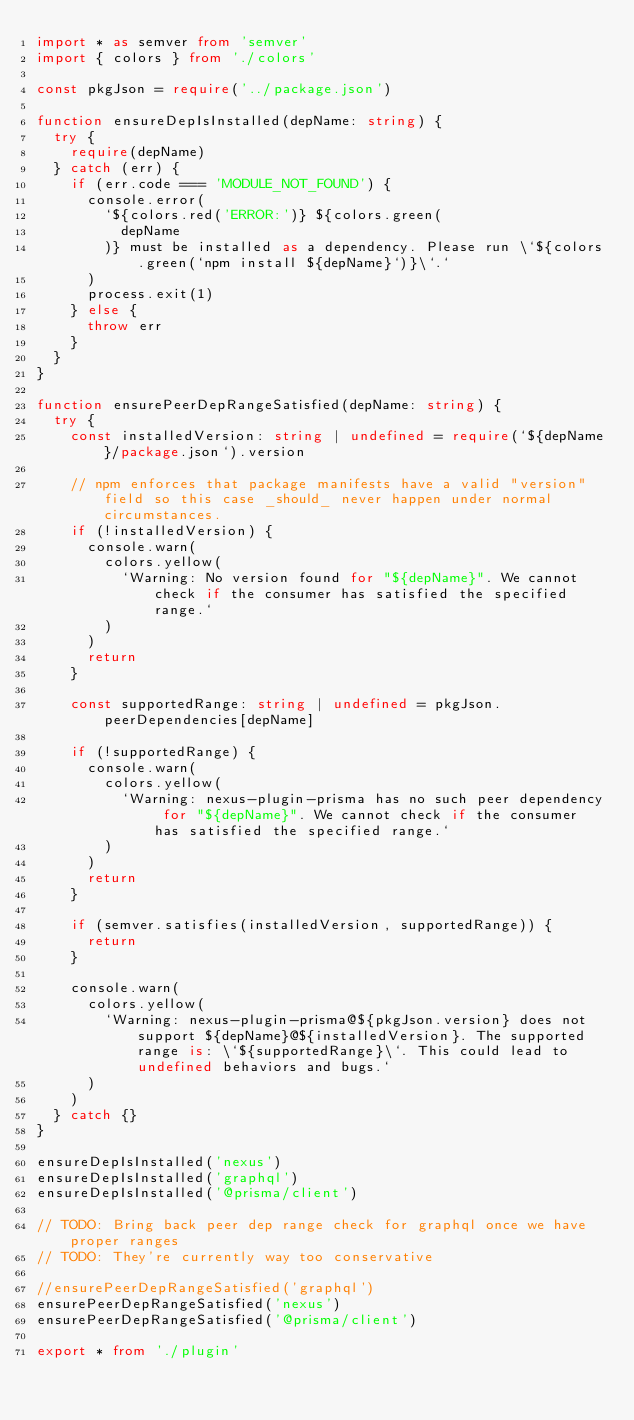Convert code to text. <code><loc_0><loc_0><loc_500><loc_500><_TypeScript_>import * as semver from 'semver'
import { colors } from './colors'

const pkgJson = require('../package.json')

function ensureDepIsInstalled(depName: string) {
  try {
    require(depName)
  } catch (err) {
    if (err.code === 'MODULE_NOT_FOUND') {
      console.error(
        `${colors.red('ERROR:')} ${colors.green(
          depName
        )} must be installed as a dependency. Please run \`${colors.green(`npm install ${depName}`)}\`.`
      )
      process.exit(1)
    } else {
      throw err
    }
  }
}

function ensurePeerDepRangeSatisfied(depName: string) {
  try {
    const installedVersion: string | undefined = require(`${depName}/package.json`).version

    // npm enforces that package manifests have a valid "version" field so this case _should_ never happen under normal circumstances.
    if (!installedVersion) {
      console.warn(
        colors.yellow(
          `Warning: No version found for "${depName}". We cannot check if the consumer has satisfied the specified range.`
        )
      )
      return
    }

    const supportedRange: string | undefined = pkgJson.peerDependencies[depName]

    if (!supportedRange) {
      console.warn(
        colors.yellow(
          `Warning: nexus-plugin-prisma has no such peer dependency for "${depName}". We cannot check if the consumer has satisfied the specified range.`
        )
      )
      return
    }

    if (semver.satisfies(installedVersion, supportedRange)) {
      return
    }

    console.warn(
      colors.yellow(
        `Warning: nexus-plugin-prisma@${pkgJson.version} does not support ${depName}@${installedVersion}. The supported range is: \`${supportedRange}\`. This could lead to undefined behaviors and bugs.`
      )
    )
  } catch {}
}

ensureDepIsInstalled('nexus')
ensureDepIsInstalled('graphql')
ensureDepIsInstalled('@prisma/client')

// TODO: Bring back peer dep range check for graphql once we have proper ranges
// TODO: They're currently way too conservative

//ensurePeerDepRangeSatisfied('graphql')
ensurePeerDepRangeSatisfied('nexus')
ensurePeerDepRangeSatisfied('@prisma/client')

export * from './plugin'
</code> 